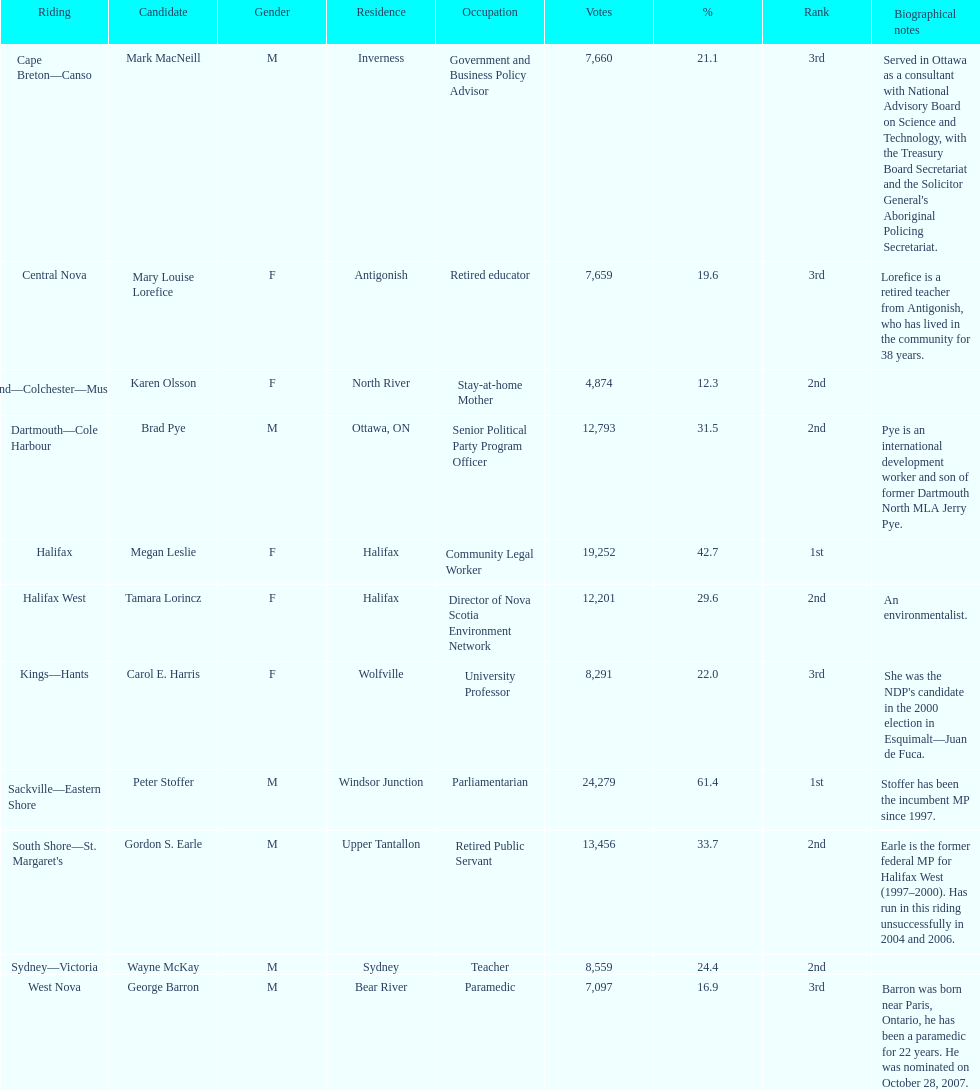Who has the greatest amount of votes? Sackville-Eastern Shore. Could you help me parse every detail presented in this table? {'header': ['Riding', 'Candidate', 'Gender', 'Residence', 'Occupation', 'Votes', '%', 'Rank', 'Biographical notes'], 'rows': [['Cape Breton—Canso', 'Mark MacNeill', 'M', 'Inverness', 'Government and Business Policy Advisor', '7,660', '21.1', '3rd', "Served in Ottawa as a consultant with National Advisory Board on Science and Technology, with the Treasury Board Secretariat and the Solicitor General's Aboriginal Policing Secretariat."], ['Central Nova', 'Mary Louise Lorefice', 'F', 'Antigonish', 'Retired educator', '7,659', '19.6', '3rd', 'Lorefice is a retired teacher from Antigonish, who has lived in the community for 38 years.'], ['Cumberland—Colchester—Musquodoboit Valley', 'Karen Olsson', 'F', 'North River', 'Stay-at-home Mother', '4,874', '12.3', '2nd', ''], ['Dartmouth—Cole Harbour', 'Brad Pye', 'M', 'Ottawa, ON', 'Senior Political Party Program Officer', '12,793', '31.5', '2nd', 'Pye is an international development worker and son of former Dartmouth North MLA Jerry Pye.'], ['Halifax', 'Megan Leslie', 'F', 'Halifax', 'Community Legal Worker', '19,252', '42.7', '1st', ''], ['Halifax West', 'Tamara Lorincz', 'F', 'Halifax', 'Director of Nova Scotia Environment Network', '12,201', '29.6', '2nd', 'An environmentalist.'], ['Kings—Hants', 'Carol E. Harris', 'F', 'Wolfville', 'University Professor', '8,291', '22.0', '3rd', "She was the NDP's candidate in the 2000 election in Esquimalt—Juan de Fuca."], ['Sackville—Eastern Shore', 'Peter Stoffer', 'M', 'Windsor Junction', 'Parliamentarian', '24,279', '61.4', '1st', 'Stoffer has been the incumbent MP since 1997.'], ["South Shore—St. Margaret's", 'Gordon S. Earle', 'M', 'Upper Tantallon', 'Retired Public Servant', '13,456', '33.7', '2nd', 'Earle is the former federal MP for Halifax West (1997–2000). Has run in this riding unsuccessfully in 2004 and 2006.'], ['Sydney—Victoria', 'Wayne McKay', 'M', 'Sydney', 'Teacher', '8,559', '24.4', '2nd', ''], ['West Nova', 'George Barron', 'M', 'Bear River', 'Paramedic', '7,097', '16.9', '3rd', 'Barron was born near Paris, Ontario, he has been a paramedic for 22 years. He was nominated on October 28, 2007.']]} 